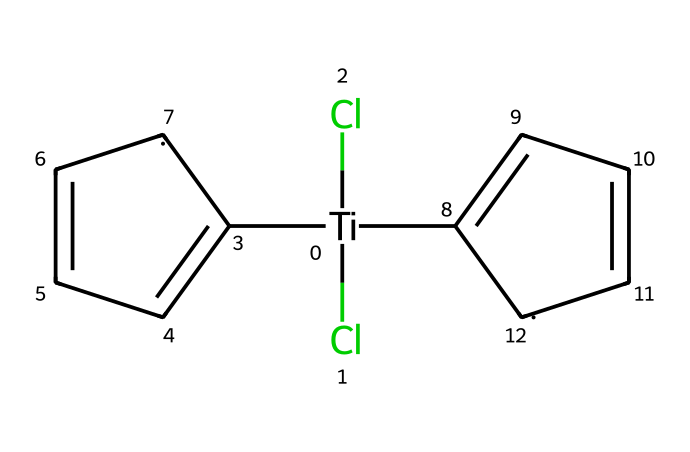What is the central metal in this compound? The central metal can be identified directly from the chemical structure, denoted by the element symbol 'Ti' in the SMILES representation, indicating that titanium is the central atom.
Answer: titanium How many chlorine atoms are present in the structure? By analyzing the SMILES notation, we can see 'Cl' appears twice, indicating that there are two chlorine atoms attached to the titanium.
Answer: two What type of ligands are connected to the titanium in this compound? The ligands attached to titanium can be identified as cyclopentadienyl groups because of the structure represented by ‘C1=CC=C[CH]1’ in the SMILES, which indicates two cyclopentadienyl rings.
Answer: cyclopentadienyl What is the total number of carbon atoms in the compound? Each cyclopentadienyl group has five carbon atoms, and since there are two of them, we multiply by 2, resulting in a total of 10 carbon atoms.
Answer: ten How does this compound categorize in terms of chemical type? This compound incorporates a metal (titanium) bonded to organic ligands (cyclopentadienyls), classifying it as an organometallic compound, which is a hallmark of the organometallic category.
Answer: organometallic What is the hybridization of the titanium atom in this complex? The coordination of titanium with two chlorine atoms and two cyclopentadienyl ligands suggests a coordination number of 4, typically leading to sp3 hybridization in organometallic complexes like this one.
Answer: sp3 What type of plastic is commonly produced using catalysts like this one? The use of bis(cyclopentadienyl)titanium dichloride as a catalyst is popular in the polymerization process, especially for producing polyethylene, which is widely used in various plastic products.
Answer: polyethylene 